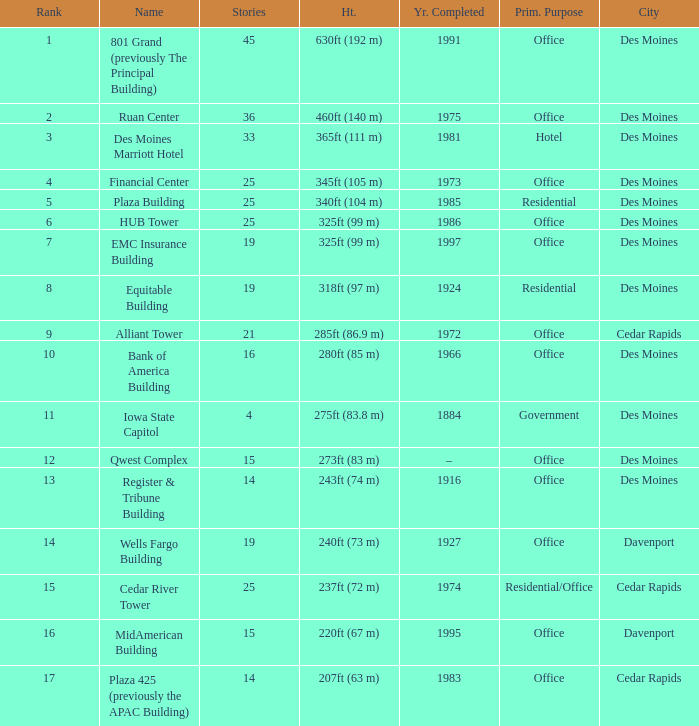What is the height of the EMC Insurance Building in Des Moines? 325ft (99 m). 